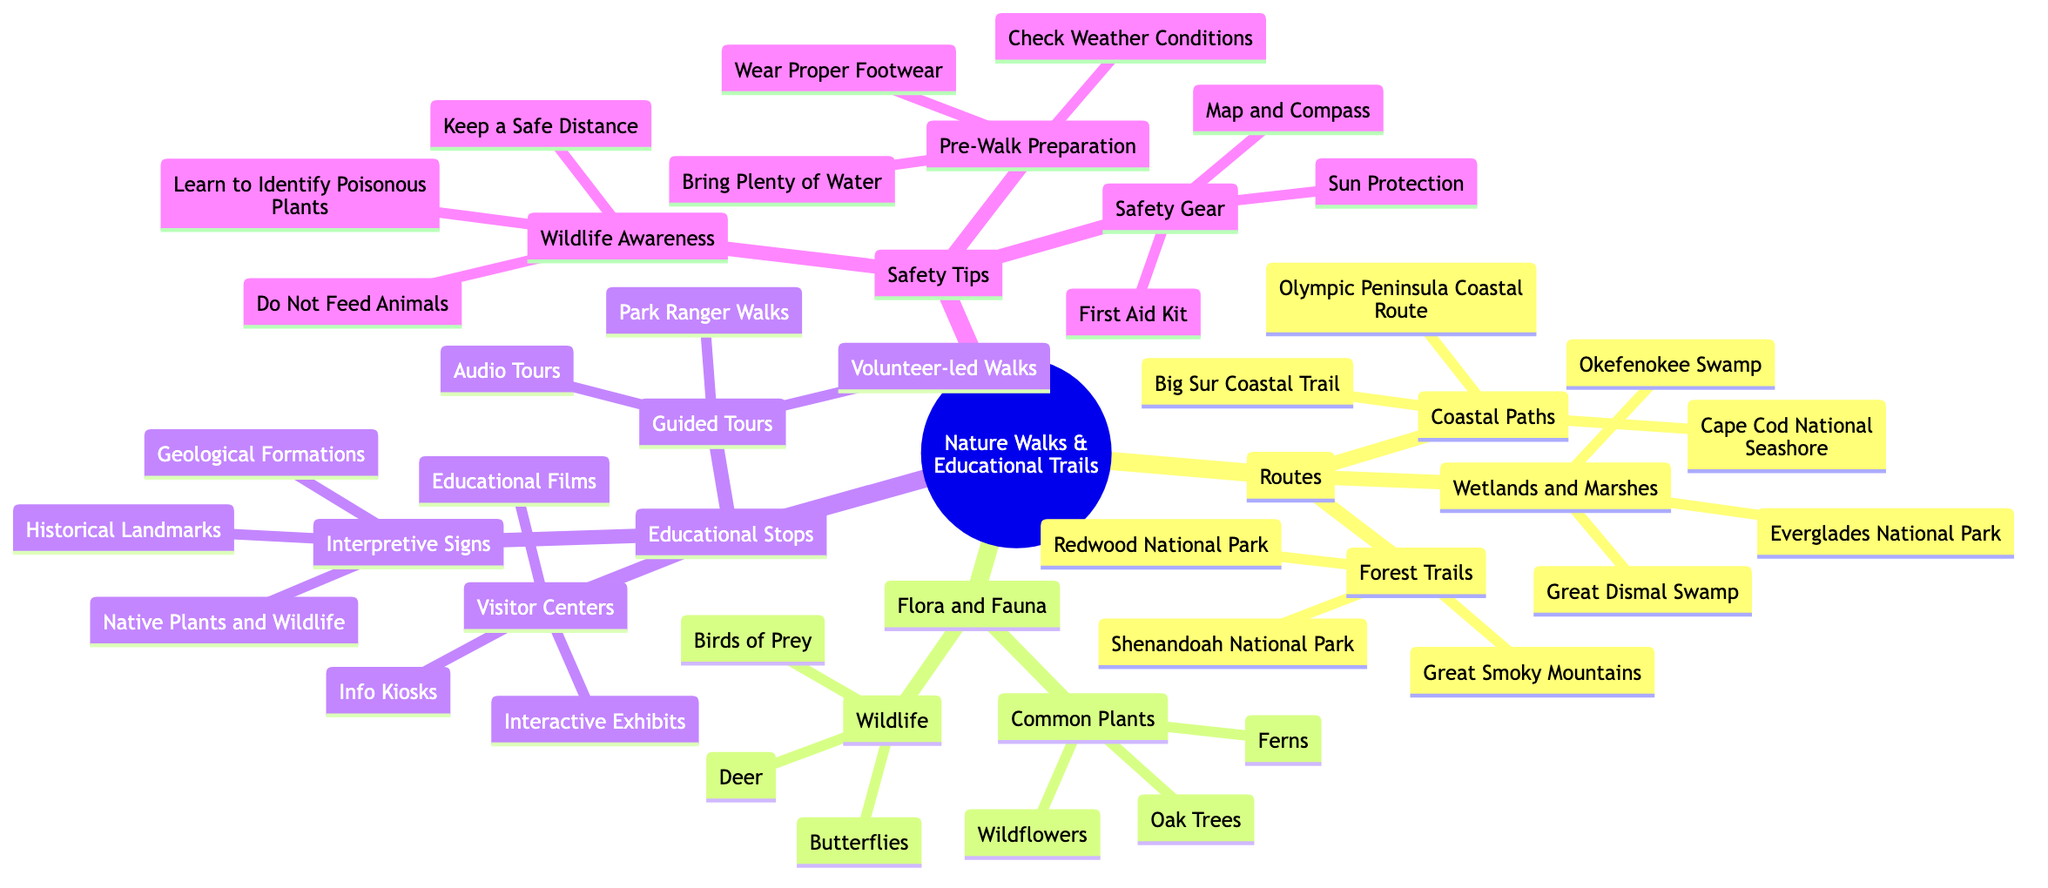What are the three types of routes mentioned? The diagram lists three categories under "Routes": Forest Trails, Coastal Paths, and Wetlands and Marshes.
Answer: Forest Trails, Coastal Paths, Wetlands and Marshes How many common plants are noted in the flora section? The Flora and Fauna section includes one subset labeled "Common Plants," which contains three specific plants: Oak Trees, Ferns, and Wildflowers.
Answer: 3 What educational stops are available at visitor centers? The diagram specifically lists three types of educational stops under "Visitor Centers": Interactive Exhibits, Educational Films, and Info Kiosks.
Answer: Interactive Exhibits, Educational Films, Info Kiosks What should you check before going on a nature walk? The safety tips section under "Pre-Walk Preparation" states that one should check weather conditions as part of the preparation before starting a walk.
Answer: Check Weather Conditions How do interpretive signs enhance nature walks? Interpretive signs help visitors understand the environment better by providing information on Geological Formations, Historical Landmarks, and Native Plants and Wildlife, facilitating learning during the walk.
Answer: They provide educational information 